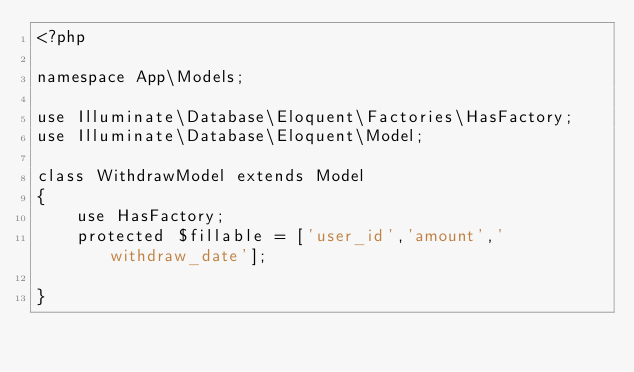Convert code to text. <code><loc_0><loc_0><loc_500><loc_500><_PHP_><?php

namespace App\Models;

use Illuminate\Database\Eloquent\Factories\HasFactory;
use Illuminate\Database\Eloquent\Model;

class WithdrawModel extends Model
{
    use HasFactory;
    protected $fillable = ['user_id','amount','withdraw_date'];

}
</code> 